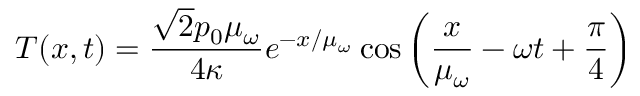Convert formula to latex. <formula><loc_0><loc_0><loc_500><loc_500>T ( x , t ) = \frac { \sqrt { 2 } p _ { 0 } \mu _ { \omega } } { 4 \kappa } e ^ { - x / \mu _ { \omega } } \cos { \left ( \frac { x } { \mu _ { \omega } } - \omega t + \frac { \pi } { 4 } \right ) }</formula> 